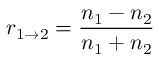Convert formula to latex. <formula><loc_0><loc_0><loc_500><loc_500>r _ { 1 \rightarrow 2 } = \frac { n _ { 1 } - n _ { 2 } } { n _ { 1 } + n _ { 2 } }</formula> 